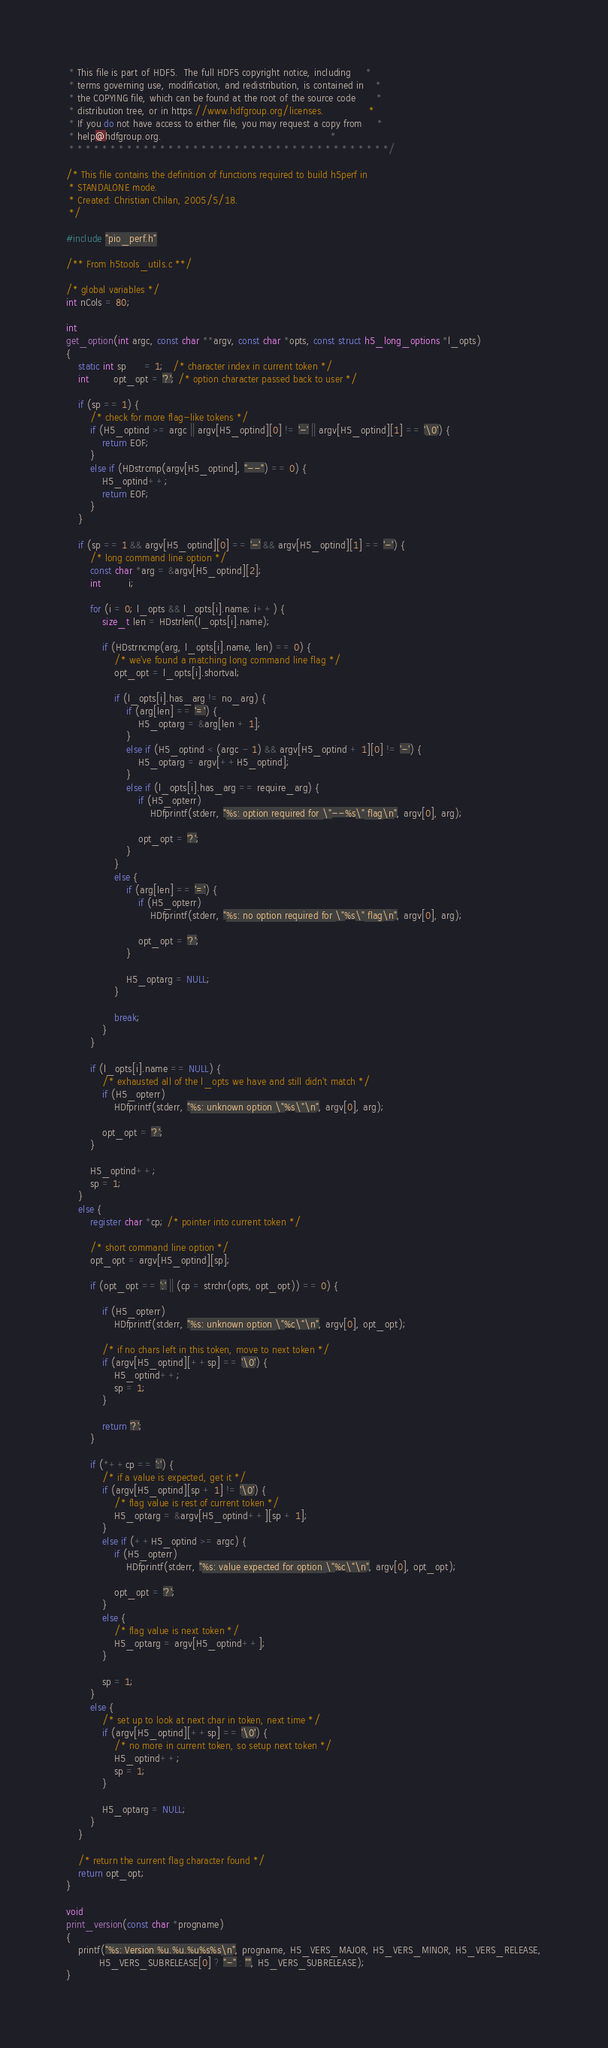Convert code to text. <code><loc_0><loc_0><loc_500><loc_500><_C_> * This file is part of HDF5.  The full HDF5 copyright notice, including     *
 * terms governing use, modification, and redistribution, is contained in    *
 * the COPYING file, which can be found at the root of the source code       *
 * distribution tree, or in https://www.hdfgroup.org/licenses.               *
 * If you do not have access to either file, you may request a copy from     *
 * help@hdfgroup.org.                                                        *
 * * * * * * * * * * * * * * * * * * * * * * * * * * * * * * * * * * * * * * */

/* This file contains the definition of functions required to build h5perf in
 * STANDALONE mode.
 * Created: Christian Chilan, 2005/5/18.
 */

#include "pio_perf.h"

/** From h5tools_utils.c **/

/* global variables */
int nCols = 80;

int
get_option(int argc, const char **argv, const char *opts, const struct h5_long_options *l_opts)
{
    static int sp      = 1;   /* character index in current token */
    int        opt_opt = '?'; /* option character passed back to user */

    if (sp == 1) {
        /* check for more flag-like tokens */
        if (H5_optind >= argc || argv[H5_optind][0] != '-' || argv[H5_optind][1] == '\0') {
            return EOF;
        }
        else if (HDstrcmp(argv[H5_optind], "--") == 0) {
            H5_optind++;
            return EOF;
        }
    }

    if (sp == 1 && argv[H5_optind][0] == '-' && argv[H5_optind][1] == '-') {
        /* long command line option */
        const char *arg = &argv[H5_optind][2];
        int         i;

        for (i = 0; l_opts && l_opts[i].name; i++) {
            size_t len = HDstrlen(l_opts[i].name);

            if (HDstrncmp(arg, l_opts[i].name, len) == 0) {
                /* we've found a matching long command line flag */
                opt_opt = l_opts[i].shortval;

                if (l_opts[i].has_arg != no_arg) {
                    if (arg[len] == '=') {
                        H5_optarg = &arg[len + 1];
                    }
                    else if (H5_optind < (argc - 1) && argv[H5_optind + 1][0] != '-') {
                        H5_optarg = argv[++H5_optind];
                    }
                    else if (l_opts[i].has_arg == require_arg) {
                        if (H5_opterr)
                            HDfprintf(stderr, "%s: option required for \"--%s\" flag\n", argv[0], arg);

                        opt_opt = '?';
                    }
                }
                else {
                    if (arg[len] == '=') {
                        if (H5_opterr)
                            HDfprintf(stderr, "%s: no option required for \"%s\" flag\n", argv[0], arg);

                        opt_opt = '?';
                    }

                    H5_optarg = NULL;
                }

                break;
            }
        }

        if (l_opts[i].name == NULL) {
            /* exhausted all of the l_opts we have and still didn't match */
            if (H5_opterr)
                HDfprintf(stderr, "%s: unknown option \"%s\"\n", argv[0], arg);

            opt_opt = '?';
        }

        H5_optind++;
        sp = 1;
    }
    else {
        register char *cp; /* pointer into current token */

        /* short command line option */
        opt_opt = argv[H5_optind][sp];

        if (opt_opt == ':' || (cp = strchr(opts, opt_opt)) == 0) {

            if (H5_opterr)
                HDfprintf(stderr, "%s: unknown option \"%c\"\n", argv[0], opt_opt);

            /* if no chars left in this token, move to next token */
            if (argv[H5_optind][++sp] == '\0') {
                H5_optind++;
                sp = 1;
            }

            return '?';
        }

        if (*++cp == ':') {
            /* if a value is expected, get it */
            if (argv[H5_optind][sp + 1] != '\0') {
                /* flag value is rest of current token */
                H5_optarg = &argv[H5_optind++][sp + 1];
            }
            else if (++H5_optind >= argc) {
                if (H5_opterr)
                    HDfprintf(stderr, "%s: value expected for option \"%c\"\n", argv[0], opt_opt);

                opt_opt = '?';
            }
            else {
                /* flag value is next token */
                H5_optarg = argv[H5_optind++];
            }

            sp = 1;
        }
        else {
            /* set up to look at next char in token, next time */
            if (argv[H5_optind][++sp] == '\0') {
                /* no more in current token, so setup next token */
                H5_optind++;
                sp = 1;
            }

            H5_optarg = NULL;
        }
    }

    /* return the current flag character found */
    return opt_opt;
}

void
print_version(const char *progname)
{
    printf("%s: Version %u.%u.%u%s%s\n", progname, H5_VERS_MAJOR, H5_VERS_MINOR, H5_VERS_RELEASE,
           H5_VERS_SUBRELEASE[0] ? "-" : "", H5_VERS_SUBRELEASE);
}
</code> 